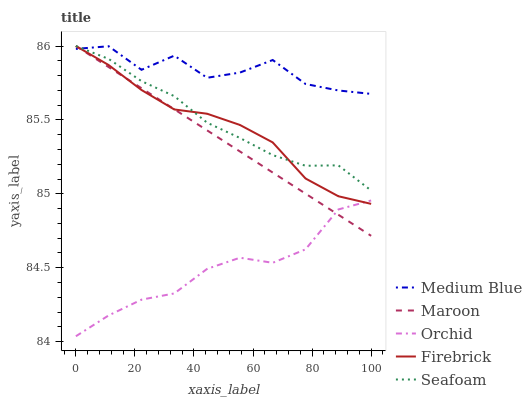Does Seafoam have the minimum area under the curve?
Answer yes or no. No. Does Seafoam have the maximum area under the curve?
Answer yes or no. No. Is Seafoam the smoothest?
Answer yes or no. No. Is Seafoam the roughest?
Answer yes or no. No. Does Seafoam have the lowest value?
Answer yes or no. No. Does Medium Blue have the highest value?
Answer yes or no. No. Is Orchid less than Medium Blue?
Answer yes or no. Yes. Is Medium Blue greater than Orchid?
Answer yes or no. Yes. Does Orchid intersect Medium Blue?
Answer yes or no. No. 